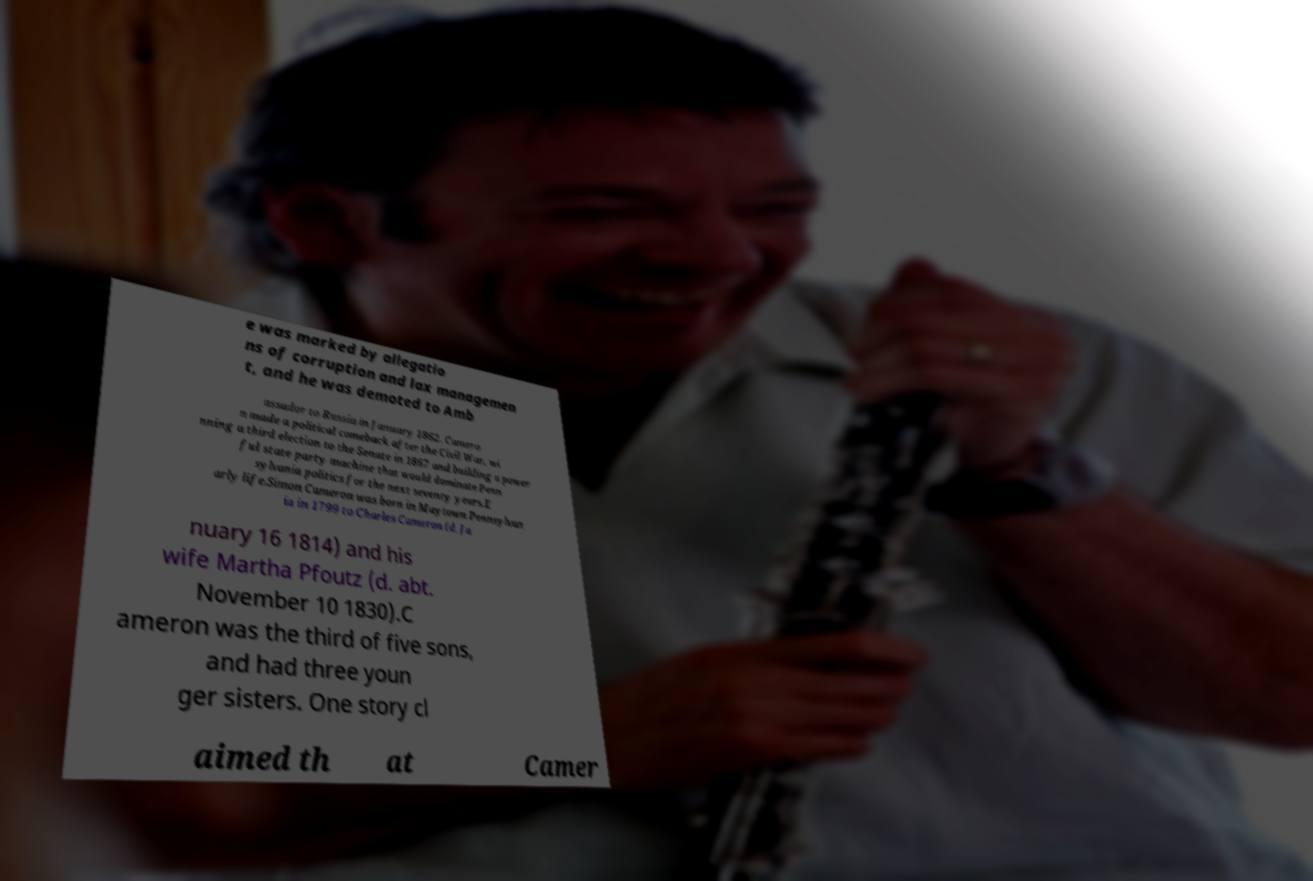Could you assist in decoding the text presented in this image and type it out clearly? e was marked by allegatio ns of corruption and lax managemen t, and he was demoted to Amb assador to Russia in January 1862. Camero n made a political comeback after the Civil War, wi nning a third election to the Senate in 1867 and building a power ful state party machine that would dominate Penn sylvania politics for the next seventy years.E arly life.Simon Cameron was born in Maytown Pennsylvan ia in 1799 to Charles Cameron (d. Ja nuary 16 1814) and his wife Martha Pfoutz (d. abt. November 10 1830).C ameron was the third of five sons, and had three youn ger sisters. One story cl aimed th at Camer 